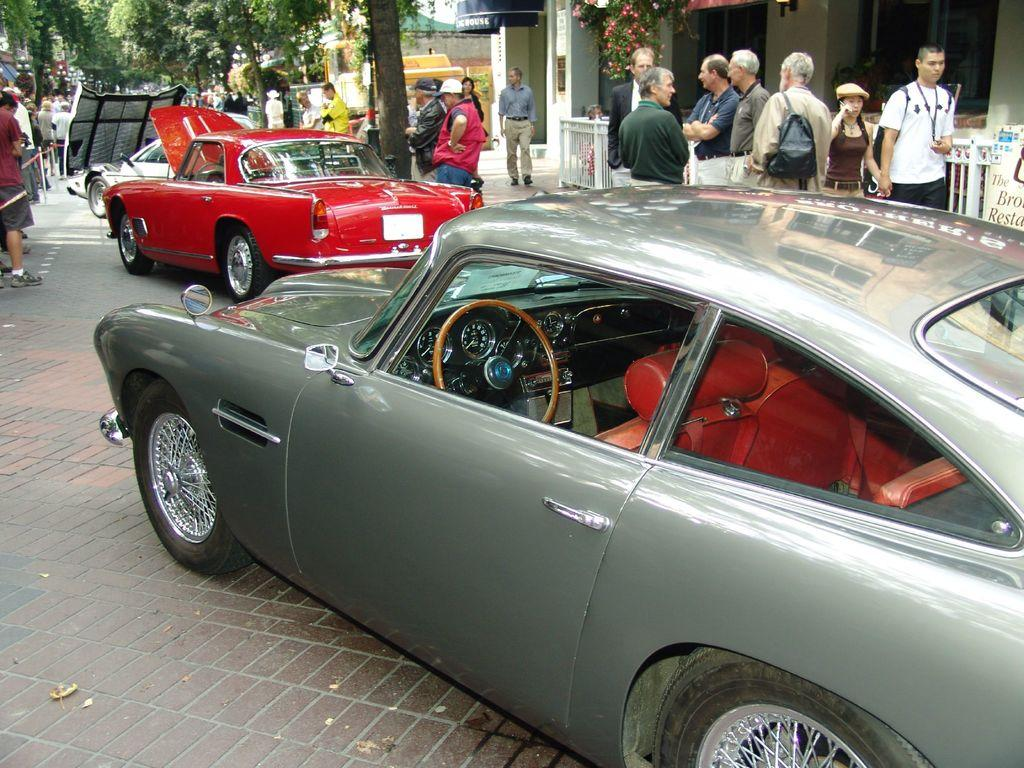What is located in the foreground of the image? There are fleets of cars and a crowd on the road in the foreground of the image. What can be seen in the background of the image? There is a building, trees, a fence, and the sky visible in the background of the image. Can you describe the time of day when the image was taken? The image was taken during the day. What type of cloth is draped over the fence in the image? There is no cloth draped over the fence in the image. How does the pail of water taste in the image? There is no pail of water present in the image, so it cannot be tasted. 